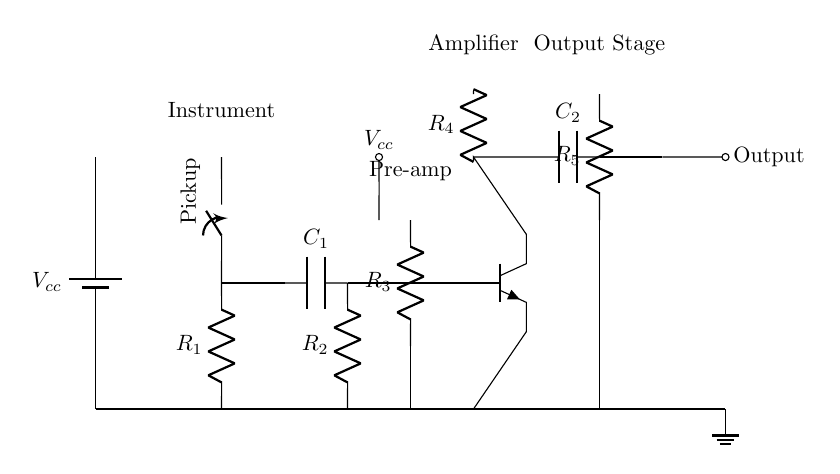What type of transistor is used in the circuit? The circuit diagram shows an npn transistor labeled Q1, indicating that the type of transistor used is a bipolar junction transistor where the current flows from the collector to the emitter when the base is forward-biased.
Answer: npn What is the purpose of the capacitor labeled C1 in the pre-amp section? The capacitor C1 is used for coupling, which means it allows AC signals to pass while blocking DC signals. This is crucial for amplifying the audio signal from the instrument without affecting its characteristics.
Answer: Coupling How many resistors are present in the amplifier circuit? The circuit shows a total of five resistors: R1, R2, R3, R4, and R5, indicating these components are utilized for biasing, loading, and signal conditioning within the amplifier circuit.
Answer: Five Which component provides the power supply for the circuit? The battery labeled Vcc at the start of the circuit represents the power supply that provides the necessary voltage for the circuit operation, powering all components including the amplifier and those involved in signal conditioning.
Answer: Battery What is the function of the capacitor labeled C2 in the output stage? Capacitor C2 in the output stage acts as a coupling capacitor that allows the amplified signal to pass to the output while blocking any DC offset from the amplifier output, ensuring that only the AC signal is sent to the load.
Answer: Coupling What is the value of the current flowing through R4? The exact value of the current flowing through R4 cannot be determined without additional information such as the voltage across it and its resistance value; however, it serves as a load for the amplifier output.
Answer: Indeterminate What is the role of resistor R3? Resistor R3 is connected between the collector and emitter of the transistor and serves as a load, impacting the gain of the amplifier and helping to stabilize the operation of the transistor.
Answer: Load 